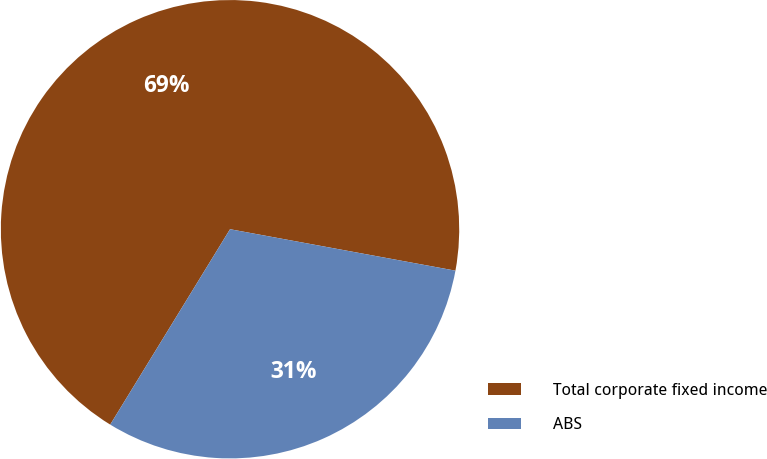Convert chart. <chart><loc_0><loc_0><loc_500><loc_500><pie_chart><fcel>Total corporate fixed income<fcel>ABS<nl><fcel>69.14%<fcel>30.86%<nl></chart> 